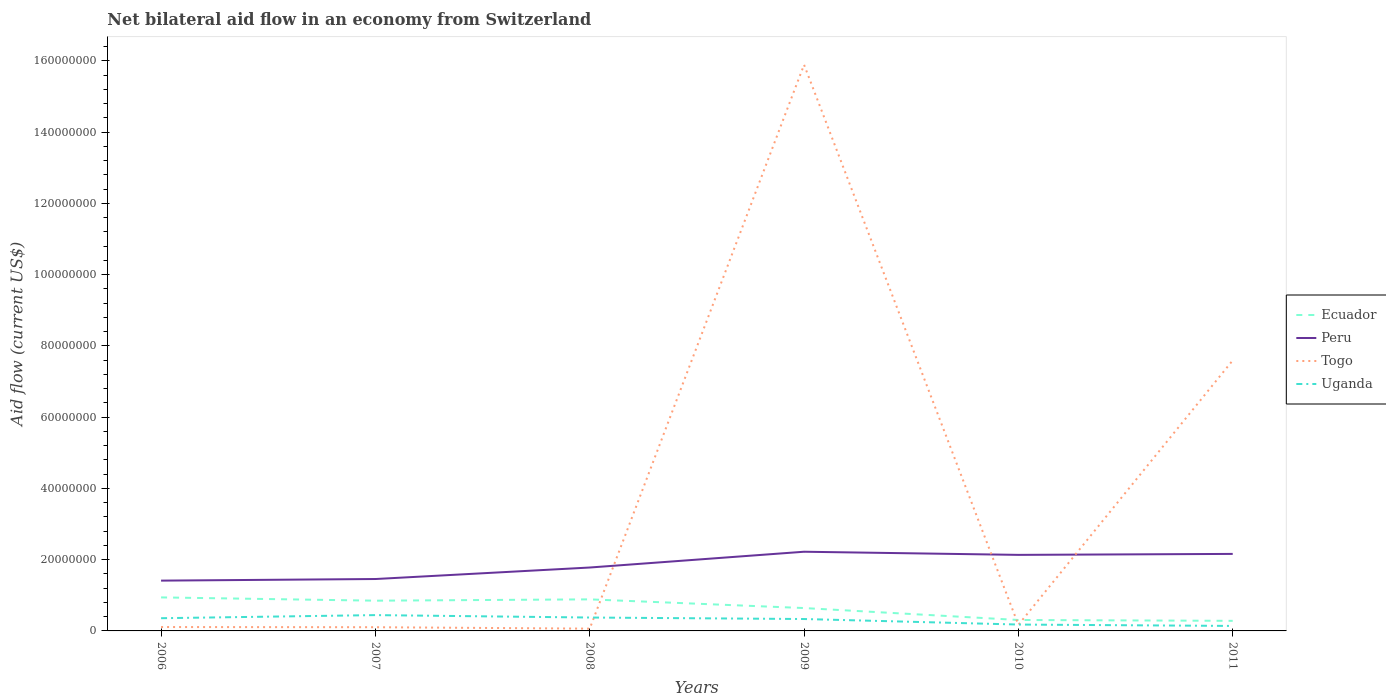How many different coloured lines are there?
Give a very brief answer. 4. Does the line corresponding to Ecuador intersect with the line corresponding to Uganda?
Your answer should be very brief. No. Across all years, what is the maximum net bilateral aid flow in Ecuador?
Your response must be concise. 2.83e+06. In which year was the net bilateral aid flow in Ecuador maximum?
Make the answer very short. 2011. What is the total net bilateral aid flow in Togo in the graph?
Your answer should be very brief. -1.58e+08. What is the difference between the highest and the second highest net bilateral aid flow in Uganda?
Give a very brief answer. 3.04e+06. What is the difference between the highest and the lowest net bilateral aid flow in Togo?
Offer a terse response. 2. How many years are there in the graph?
Ensure brevity in your answer.  6. Does the graph contain grids?
Offer a very short reply. No. How many legend labels are there?
Ensure brevity in your answer.  4. What is the title of the graph?
Your answer should be compact. Net bilateral aid flow in an economy from Switzerland. What is the label or title of the Y-axis?
Offer a terse response. Aid flow (current US$). What is the Aid flow (current US$) in Ecuador in 2006?
Keep it short and to the point. 9.41e+06. What is the Aid flow (current US$) of Peru in 2006?
Ensure brevity in your answer.  1.41e+07. What is the Aid flow (current US$) in Togo in 2006?
Provide a short and direct response. 1.09e+06. What is the Aid flow (current US$) of Uganda in 2006?
Your answer should be compact. 3.57e+06. What is the Aid flow (current US$) in Ecuador in 2007?
Ensure brevity in your answer.  8.49e+06. What is the Aid flow (current US$) of Peru in 2007?
Offer a terse response. 1.46e+07. What is the Aid flow (current US$) in Togo in 2007?
Keep it short and to the point. 1.04e+06. What is the Aid flow (current US$) of Uganda in 2007?
Make the answer very short. 4.44e+06. What is the Aid flow (current US$) in Ecuador in 2008?
Give a very brief answer. 8.86e+06. What is the Aid flow (current US$) of Peru in 2008?
Provide a short and direct response. 1.78e+07. What is the Aid flow (current US$) in Togo in 2008?
Provide a short and direct response. 6.40e+05. What is the Aid flow (current US$) of Uganda in 2008?
Provide a short and direct response. 3.76e+06. What is the Aid flow (current US$) in Ecuador in 2009?
Offer a very short reply. 6.42e+06. What is the Aid flow (current US$) of Peru in 2009?
Your response must be concise. 2.22e+07. What is the Aid flow (current US$) of Togo in 2009?
Ensure brevity in your answer.  1.59e+08. What is the Aid flow (current US$) of Uganda in 2009?
Your answer should be very brief. 3.34e+06. What is the Aid flow (current US$) of Ecuador in 2010?
Ensure brevity in your answer.  3.07e+06. What is the Aid flow (current US$) in Peru in 2010?
Your answer should be very brief. 2.14e+07. What is the Aid flow (current US$) in Togo in 2010?
Provide a short and direct response. 1.71e+06. What is the Aid flow (current US$) of Uganda in 2010?
Your answer should be compact. 1.79e+06. What is the Aid flow (current US$) in Ecuador in 2011?
Offer a very short reply. 2.83e+06. What is the Aid flow (current US$) of Peru in 2011?
Make the answer very short. 2.16e+07. What is the Aid flow (current US$) in Togo in 2011?
Provide a short and direct response. 7.60e+07. What is the Aid flow (current US$) of Uganda in 2011?
Provide a short and direct response. 1.40e+06. Across all years, what is the maximum Aid flow (current US$) of Ecuador?
Your answer should be very brief. 9.41e+06. Across all years, what is the maximum Aid flow (current US$) in Peru?
Provide a succinct answer. 2.22e+07. Across all years, what is the maximum Aid flow (current US$) in Togo?
Your response must be concise. 1.59e+08. Across all years, what is the maximum Aid flow (current US$) in Uganda?
Offer a terse response. 4.44e+06. Across all years, what is the minimum Aid flow (current US$) in Ecuador?
Give a very brief answer. 2.83e+06. Across all years, what is the minimum Aid flow (current US$) of Peru?
Keep it short and to the point. 1.41e+07. Across all years, what is the minimum Aid flow (current US$) of Togo?
Keep it short and to the point. 6.40e+05. Across all years, what is the minimum Aid flow (current US$) in Uganda?
Give a very brief answer. 1.40e+06. What is the total Aid flow (current US$) in Ecuador in the graph?
Ensure brevity in your answer.  3.91e+07. What is the total Aid flow (current US$) of Peru in the graph?
Offer a very short reply. 1.12e+08. What is the total Aid flow (current US$) in Togo in the graph?
Ensure brevity in your answer.  2.39e+08. What is the total Aid flow (current US$) of Uganda in the graph?
Offer a terse response. 1.83e+07. What is the difference between the Aid flow (current US$) in Ecuador in 2006 and that in 2007?
Offer a terse response. 9.20e+05. What is the difference between the Aid flow (current US$) of Peru in 2006 and that in 2007?
Your response must be concise. -4.50e+05. What is the difference between the Aid flow (current US$) in Togo in 2006 and that in 2007?
Give a very brief answer. 5.00e+04. What is the difference between the Aid flow (current US$) in Uganda in 2006 and that in 2007?
Give a very brief answer. -8.70e+05. What is the difference between the Aid flow (current US$) in Ecuador in 2006 and that in 2008?
Make the answer very short. 5.50e+05. What is the difference between the Aid flow (current US$) in Peru in 2006 and that in 2008?
Your response must be concise. -3.68e+06. What is the difference between the Aid flow (current US$) in Ecuador in 2006 and that in 2009?
Your answer should be very brief. 2.99e+06. What is the difference between the Aid flow (current US$) of Peru in 2006 and that in 2009?
Give a very brief answer. -8.11e+06. What is the difference between the Aid flow (current US$) of Togo in 2006 and that in 2009?
Make the answer very short. -1.58e+08. What is the difference between the Aid flow (current US$) in Uganda in 2006 and that in 2009?
Provide a short and direct response. 2.30e+05. What is the difference between the Aid flow (current US$) in Ecuador in 2006 and that in 2010?
Give a very brief answer. 6.34e+06. What is the difference between the Aid flow (current US$) of Peru in 2006 and that in 2010?
Make the answer very short. -7.23e+06. What is the difference between the Aid flow (current US$) in Togo in 2006 and that in 2010?
Keep it short and to the point. -6.20e+05. What is the difference between the Aid flow (current US$) of Uganda in 2006 and that in 2010?
Provide a short and direct response. 1.78e+06. What is the difference between the Aid flow (current US$) in Ecuador in 2006 and that in 2011?
Give a very brief answer. 6.58e+06. What is the difference between the Aid flow (current US$) of Peru in 2006 and that in 2011?
Offer a terse response. -7.50e+06. What is the difference between the Aid flow (current US$) in Togo in 2006 and that in 2011?
Ensure brevity in your answer.  -7.49e+07. What is the difference between the Aid flow (current US$) of Uganda in 2006 and that in 2011?
Make the answer very short. 2.17e+06. What is the difference between the Aid flow (current US$) of Ecuador in 2007 and that in 2008?
Offer a terse response. -3.70e+05. What is the difference between the Aid flow (current US$) in Peru in 2007 and that in 2008?
Provide a succinct answer. -3.23e+06. What is the difference between the Aid flow (current US$) of Uganda in 2007 and that in 2008?
Make the answer very short. 6.80e+05. What is the difference between the Aid flow (current US$) in Ecuador in 2007 and that in 2009?
Provide a succinct answer. 2.07e+06. What is the difference between the Aid flow (current US$) of Peru in 2007 and that in 2009?
Provide a short and direct response. -7.66e+06. What is the difference between the Aid flow (current US$) in Togo in 2007 and that in 2009?
Keep it short and to the point. -1.58e+08. What is the difference between the Aid flow (current US$) in Uganda in 2007 and that in 2009?
Offer a terse response. 1.10e+06. What is the difference between the Aid flow (current US$) in Ecuador in 2007 and that in 2010?
Provide a short and direct response. 5.42e+06. What is the difference between the Aid flow (current US$) of Peru in 2007 and that in 2010?
Your answer should be very brief. -6.78e+06. What is the difference between the Aid flow (current US$) in Togo in 2007 and that in 2010?
Offer a terse response. -6.70e+05. What is the difference between the Aid flow (current US$) in Uganda in 2007 and that in 2010?
Your answer should be very brief. 2.65e+06. What is the difference between the Aid flow (current US$) of Ecuador in 2007 and that in 2011?
Your response must be concise. 5.66e+06. What is the difference between the Aid flow (current US$) of Peru in 2007 and that in 2011?
Your answer should be compact. -7.05e+06. What is the difference between the Aid flow (current US$) in Togo in 2007 and that in 2011?
Make the answer very short. -7.49e+07. What is the difference between the Aid flow (current US$) in Uganda in 2007 and that in 2011?
Keep it short and to the point. 3.04e+06. What is the difference between the Aid flow (current US$) of Ecuador in 2008 and that in 2009?
Offer a very short reply. 2.44e+06. What is the difference between the Aid flow (current US$) of Peru in 2008 and that in 2009?
Make the answer very short. -4.43e+06. What is the difference between the Aid flow (current US$) of Togo in 2008 and that in 2009?
Give a very brief answer. -1.58e+08. What is the difference between the Aid flow (current US$) of Ecuador in 2008 and that in 2010?
Ensure brevity in your answer.  5.79e+06. What is the difference between the Aid flow (current US$) of Peru in 2008 and that in 2010?
Give a very brief answer. -3.55e+06. What is the difference between the Aid flow (current US$) of Togo in 2008 and that in 2010?
Provide a short and direct response. -1.07e+06. What is the difference between the Aid flow (current US$) in Uganda in 2008 and that in 2010?
Offer a very short reply. 1.97e+06. What is the difference between the Aid flow (current US$) of Ecuador in 2008 and that in 2011?
Your answer should be compact. 6.03e+06. What is the difference between the Aid flow (current US$) in Peru in 2008 and that in 2011?
Your answer should be compact. -3.82e+06. What is the difference between the Aid flow (current US$) in Togo in 2008 and that in 2011?
Offer a terse response. -7.53e+07. What is the difference between the Aid flow (current US$) of Uganda in 2008 and that in 2011?
Provide a succinct answer. 2.36e+06. What is the difference between the Aid flow (current US$) in Ecuador in 2009 and that in 2010?
Your answer should be compact. 3.35e+06. What is the difference between the Aid flow (current US$) in Peru in 2009 and that in 2010?
Ensure brevity in your answer.  8.80e+05. What is the difference between the Aid flow (current US$) of Togo in 2009 and that in 2010?
Offer a very short reply. 1.57e+08. What is the difference between the Aid flow (current US$) of Uganda in 2009 and that in 2010?
Provide a short and direct response. 1.55e+06. What is the difference between the Aid flow (current US$) in Ecuador in 2009 and that in 2011?
Ensure brevity in your answer.  3.59e+06. What is the difference between the Aid flow (current US$) in Peru in 2009 and that in 2011?
Keep it short and to the point. 6.10e+05. What is the difference between the Aid flow (current US$) of Togo in 2009 and that in 2011?
Make the answer very short. 8.30e+07. What is the difference between the Aid flow (current US$) of Uganda in 2009 and that in 2011?
Provide a short and direct response. 1.94e+06. What is the difference between the Aid flow (current US$) in Peru in 2010 and that in 2011?
Your response must be concise. -2.70e+05. What is the difference between the Aid flow (current US$) in Togo in 2010 and that in 2011?
Keep it short and to the point. -7.42e+07. What is the difference between the Aid flow (current US$) in Ecuador in 2006 and the Aid flow (current US$) in Peru in 2007?
Keep it short and to the point. -5.16e+06. What is the difference between the Aid flow (current US$) of Ecuador in 2006 and the Aid flow (current US$) of Togo in 2007?
Keep it short and to the point. 8.37e+06. What is the difference between the Aid flow (current US$) in Ecuador in 2006 and the Aid flow (current US$) in Uganda in 2007?
Keep it short and to the point. 4.97e+06. What is the difference between the Aid flow (current US$) of Peru in 2006 and the Aid flow (current US$) of Togo in 2007?
Keep it short and to the point. 1.31e+07. What is the difference between the Aid flow (current US$) of Peru in 2006 and the Aid flow (current US$) of Uganda in 2007?
Keep it short and to the point. 9.68e+06. What is the difference between the Aid flow (current US$) in Togo in 2006 and the Aid flow (current US$) in Uganda in 2007?
Your answer should be compact. -3.35e+06. What is the difference between the Aid flow (current US$) of Ecuador in 2006 and the Aid flow (current US$) of Peru in 2008?
Offer a terse response. -8.39e+06. What is the difference between the Aid flow (current US$) of Ecuador in 2006 and the Aid flow (current US$) of Togo in 2008?
Your answer should be compact. 8.77e+06. What is the difference between the Aid flow (current US$) in Ecuador in 2006 and the Aid flow (current US$) in Uganda in 2008?
Provide a succinct answer. 5.65e+06. What is the difference between the Aid flow (current US$) of Peru in 2006 and the Aid flow (current US$) of Togo in 2008?
Your answer should be very brief. 1.35e+07. What is the difference between the Aid flow (current US$) in Peru in 2006 and the Aid flow (current US$) in Uganda in 2008?
Provide a short and direct response. 1.04e+07. What is the difference between the Aid flow (current US$) of Togo in 2006 and the Aid flow (current US$) of Uganda in 2008?
Your response must be concise. -2.67e+06. What is the difference between the Aid flow (current US$) of Ecuador in 2006 and the Aid flow (current US$) of Peru in 2009?
Give a very brief answer. -1.28e+07. What is the difference between the Aid flow (current US$) in Ecuador in 2006 and the Aid flow (current US$) in Togo in 2009?
Offer a terse response. -1.50e+08. What is the difference between the Aid flow (current US$) in Ecuador in 2006 and the Aid flow (current US$) in Uganda in 2009?
Provide a short and direct response. 6.07e+06. What is the difference between the Aid flow (current US$) of Peru in 2006 and the Aid flow (current US$) of Togo in 2009?
Ensure brevity in your answer.  -1.45e+08. What is the difference between the Aid flow (current US$) in Peru in 2006 and the Aid flow (current US$) in Uganda in 2009?
Give a very brief answer. 1.08e+07. What is the difference between the Aid flow (current US$) in Togo in 2006 and the Aid flow (current US$) in Uganda in 2009?
Ensure brevity in your answer.  -2.25e+06. What is the difference between the Aid flow (current US$) in Ecuador in 2006 and the Aid flow (current US$) in Peru in 2010?
Make the answer very short. -1.19e+07. What is the difference between the Aid flow (current US$) of Ecuador in 2006 and the Aid flow (current US$) of Togo in 2010?
Provide a succinct answer. 7.70e+06. What is the difference between the Aid flow (current US$) in Ecuador in 2006 and the Aid flow (current US$) in Uganda in 2010?
Your answer should be compact. 7.62e+06. What is the difference between the Aid flow (current US$) in Peru in 2006 and the Aid flow (current US$) in Togo in 2010?
Make the answer very short. 1.24e+07. What is the difference between the Aid flow (current US$) of Peru in 2006 and the Aid flow (current US$) of Uganda in 2010?
Your response must be concise. 1.23e+07. What is the difference between the Aid flow (current US$) in Togo in 2006 and the Aid flow (current US$) in Uganda in 2010?
Ensure brevity in your answer.  -7.00e+05. What is the difference between the Aid flow (current US$) in Ecuador in 2006 and the Aid flow (current US$) in Peru in 2011?
Your response must be concise. -1.22e+07. What is the difference between the Aid flow (current US$) in Ecuador in 2006 and the Aid flow (current US$) in Togo in 2011?
Ensure brevity in your answer.  -6.65e+07. What is the difference between the Aid flow (current US$) in Ecuador in 2006 and the Aid flow (current US$) in Uganda in 2011?
Your answer should be compact. 8.01e+06. What is the difference between the Aid flow (current US$) in Peru in 2006 and the Aid flow (current US$) in Togo in 2011?
Provide a succinct answer. -6.18e+07. What is the difference between the Aid flow (current US$) in Peru in 2006 and the Aid flow (current US$) in Uganda in 2011?
Your response must be concise. 1.27e+07. What is the difference between the Aid flow (current US$) in Togo in 2006 and the Aid flow (current US$) in Uganda in 2011?
Ensure brevity in your answer.  -3.10e+05. What is the difference between the Aid flow (current US$) in Ecuador in 2007 and the Aid flow (current US$) in Peru in 2008?
Provide a succinct answer. -9.31e+06. What is the difference between the Aid flow (current US$) in Ecuador in 2007 and the Aid flow (current US$) in Togo in 2008?
Keep it short and to the point. 7.85e+06. What is the difference between the Aid flow (current US$) in Ecuador in 2007 and the Aid flow (current US$) in Uganda in 2008?
Your answer should be very brief. 4.73e+06. What is the difference between the Aid flow (current US$) of Peru in 2007 and the Aid flow (current US$) of Togo in 2008?
Provide a succinct answer. 1.39e+07. What is the difference between the Aid flow (current US$) in Peru in 2007 and the Aid flow (current US$) in Uganda in 2008?
Your response must be concise. 1.08e+07. What is the difference between the Aid flow (current US$) in Togo in 2007 and the Aid flow (current US$) in Uganda in 2008?
Your response must be concise. -2.72e+06. What is the difference between the Aid flow (current US$) in Ecuador in 2007 and the Aid flow (current US$) in Peru in 2009?
Keep it short and to the point. -1.37e+07. What is the difference between the Aid flow (current US$) of Ecuador in 2007 and the Aid flow (current US$) of Togo in 2009?
Offer a very short reply. -1.50e+08. What is the difference between the Aid flow (current US$) of Ecuador in 2007 and the Aid flow (current US$) of Uganda in 2009?
Provide a short and direct response. 5.15e+06. What is the difference between the Aid flow (current US$) in Peru in 2007 and the Aid flow (current US$) in Togo in 2009?
Offer a terse response. -1.44e+08. What is the difference between the Aid flow (current US$) of Peru in 2007 and the Aid flow (current US$) of Uganda in 2009?
Your answer should be very brief. 1.12e+07. What is the difference between the Aid flow (current US$) of Togo in 2007 and the Aid flow (current US$) of Uganda in 2009?
Offer a terse response. -2.30e+06. What is the difference between the Aid flow (current US$) in Ecuador in 2007 and the Aid flow (current US$) in Peru in 2010?
Offer a terse response. -1.29e+07. What is the difference between the Aid flow (current US$) of Ecuador in 2007 and the Aid flow (current US$) of Togo in 2010?
Your answer should be compact. 6.78e+06. What is the difference between the Aid flow (current US$) of Ecuador in 2007 and the Aid flow (current US$) of Uganda in 2010?
Make the answer very short. 6.70e+06. What is the difference between the Aid flow (current US$) in Peru in 2007 and the Aid flow (current US$) in Togo in 2010?
Your answer should be compact. 1.29e+07. What is the difference between the Aid flow (current US$) in Peru in 2007 and the Aid flow (current US$) in Uganda in 2010?
Keep it short and to the point. 1.28e+07. What is the difference between the Aid flow (current US$) in Togo in 2007 and the Aid flow (current US$) in Uganda in 2010?
Your answer should be very brief. -7.50e+05. What is the difference between the Aid flow (current US$) in Ecuador in 2007 and the Aid flow (current US$) in Peru in 2011?
Make the answer very short. -1.31e+07. What is the difference between the Aid flow (current US$) in Ecuador in 2007 and the Aid flow (current US$) in Togo in 2011?
Your answer should be compact. -6.75e+07. What is the difference between the Aid flow (current US$) of Ecuador in 2007 and the Aid flow (current US$) of Uganda in 2011?
Keep it short and to the point. 7.09e+06. What is the difference between the Aid flow (current US$) of Peru in 2007 and the Aid flow (current US$) of Togo in 2011?
Your answer should be very brief. -6.14e+07. What is the difference between the Aid flow (current US$) of Peru in 2007 and the Aid flow (current US$) of Uganda in 2011?
Provide a short and direct response. 1.32e+07. What is the difference between the Aid flow (current US$) in Togo in 2007 and the Aid flow (current US$) in Uganda in 2011?
Give a very brief answer. -3.60e+05. What is the difference between the Aid flow (current US$) in Ecuador in 2008 and the Aid flow (current US$) in Peru in 2009?
Ensure brevity in your answer.  -1.34e+07. What is the difference between the Aid flow (current US$) of Ecuador in 2008 and the Aid flow (current US$) of Togo in 2009?
Keep it short and to the point. -1.50e+08. What is the difference between the Aid flow (current US$) in Ecuador in 2008 and the Aid flow (current US$) in Uganda in 2009?
Your answer should be very brief. 5.52e+06. What is the difference between the Aid flow (current US$) in Peru in 2008 and the Aid flow (current US$) in Togo in 2009?
Your answer should be very brief. -1.41e+08. What is the difference between the Aid flow (current US$) of Peru in 2008 and the Aid flow (current US$) of Uganda in 2009?
Your answer should be compact. 1.45e+07. What is the difference between the Aid flow (current US$) of Togo in 2008 and the Aid flow (current US$) of Uganda in 2009?
Keep it short and to the point. -2.70e+06. What is the difference between the Aid flow (current US$) in Ecuador in 2008 and the Aid flow (current US$) in Peru in 2010?
Your answer should be compact. -1.25e+07. What is the difference between the Aid flow (current US$) of Ecuador in 2008 and the Aid flow (current US$) of Togo in 2010?
Give a very brief answer. 7.15e+06. What is the difference between the Aid flow (current US$) of Ecuador in 2008 and the Aid flow (current US$) of Uganda in 2010?
Your response must be concise. 7.07e+06. What is the difference between the Aid flow (current US$) in Peru in 2008 and the Aid flow (current US$) in Togo in 2010?
Give a very brief answer. 1.61e+07. What is the difference between the Aid flow (current US$) of Peru in 2008 and the Aid flow (current US$) of Uganda in 2010?
Give a very brief answer. 1.60e+07. What is the difference between the Aid flow (current US$) in Togo in 2008 and the Aid flow (current US$) in Uganda in 2010?
Provide a short and direct response. -1.15e+06. What is the difference between the Aid flow (current US$) of Ecuador in 2008 and the Aid flow (current US$) of Peru in 2011?
Provide a succinct answer. -1.28e+07. What is the difference between the Aid flow (current US$) of Ecuador in 2008 and the Aid flow (current US$) of Togo in 2011?
Provide a succinct answer. -6.71e+07. What is the difference between the Aid flow (current US$) in Ecuador in 2008 and the Aid flow (current US$) in Uganda in 2011?
Your answer should be very brief. 7.46e+06. What is the difference between the Aid flow (current US$) of Peru in 2008 and the Aid flow (current US$) of Togo in 2011?
Provide a short and direct response. -5.82e+07. What is the difference between the Aid flow (current US$) of Peru in 2008 and the Aid flow (current US$) of Uganda in 2011?
Keep it short and to the point. 1.64e+07. What is the difference between the Aid flow (current US$) in Togo in 2008 and the Aid flow (current US$) in Uganda in 2011?
Offer a very short reply. -7.60e+05. What is the difference between the Aid flow (current US$) of Ecuador in 2009 and the Aid flow (current US$) of Peru in 2010?
Keep it short and to the point. -1.49e+07. What is the difference between the Aid flow (current US$) in Ecuador in 2009 and the Aid flow (current US$) in Togo in 2010?
Give a very brief answer. 4.71e+06. What is the difference between the Aid flow (current US$) in Ecuador in 2009 and the Aid flow (current US$) in Uganda in 2010?
Provide a short and direct response. 4.63e+06. What is the difference between the Aid flow (current US$) of Peru in 2009 and the Aid flow (current US$) of Togo in 2010?
Give a very brief answer. 2.05e+07. What is the difference between the Aid flow (current US$) of Peru in 2009 and the Aid flow (current US$) of Uganda in 2010?
Your answer should be very brief. 2.04e+07. What is the difference between the Aid flow (current US$) in Togo in 2009 and the Aid flow (current US$) in Uganda in 2010?
Provide a short and direct response. 1.57e+08. What is the difference between the Aid flow (current US$) of Ecuador in 2009 and the Aid flow (current US$) of Peru in 2011?
Provide a succinct answer. -1.52e+07. What is the difference between the Aid flow (current US$) of Ecuador in 2009 and the Aid flow (current US$) of Togo in 2011?
Offer a terse response. -6.95e+07. What is the difference between the Aid flow (current US$) of Ecuador in 2009 and the Aid flow (current US$) of Uganda in 2011?
Make the answer very short. 5.02e+06. What is the difference between the Aid flow (current US$) of Peru in 2009 and the Aid flow (current US$) of Togo in 2011?
Your answer should be very brief. -5.37e+07. What is the difference between the Aid flow (current US$) in Peru in 2009 and the Aid flow (current US$) in Uganda in 2011?
Offer a terse response. 2.08e+07. What is the difference between the Aid flow (current US$) of Togo in 2009 and the Aid flow (current US$) of Uganda in 2011?
Keep it short and to the point. 1.58e+08. What is the difference between the Aid flow (current US$) in Ecuador in 2010 and the Aid flow (current US$) in Peru in 2011?
Your response must be concise. -1.86e+07. What is the difference between the Aid flow (current US$) of Ecuador in 2010 and the Aid flow (current US$) of Togo in 2011?
Your answer should be compact. -7.29e+07. What is the difference between the Aid flow (current US$) in Ecuador in 2010 and the Aid flow (current US$) in Uganda in 2011?
Keep it short and to the point. 1.67e+06. What is the difference between the Aid flow (current US$) of Peru in 2010 and the Aid flow (current US$) of Togo in 2011?
Provide a short and direct response. -5.46e+07. What is the difference between the Aid flow (current US$) in Peru in 2010 and the Aid flow (current US$) in Uganda in 2011?
Offer a terse response. 2.00e+07. What is the difference between the Aid flow (current US$) of Togo in 2010 and the Aid flow (current US$) of Uganda in 2011?
Make the answer very short. 3.10e+05. What is the average Aid flow (current US$) of Ecuador per year?
Offer a terse response. 6.51e+06. What is the average Aid flow (current US$) in Peru per year?
Your answer should be very brief. 1.86e+07. What is the average Aid flow (current US$) in Togo per year?
Provide a short and direct response. 3.99e+07. What is the average Aid flow (current US$) in Uganda per year?
Offer a terse response. 3.05e+06. In the year 2006, what is the difference between the Aid flow (current US$) of Ecuador and Aid flow (current US$) of Peru?
Give a very brief answer. -4.71e+06. In the year 2006, what is the difference between the Aid flow (current US$) of Ecuador and Aid flow (current US$) of Togo?
Provide a short and direct response. 8.32e+06. In the year 2006, what is the difference between the Aid flow (current US$) of Ecuador and Aid flow (current US$) of Uganda?
Keep it short and to the point. 5.84e+06. In the year 2006, what is the difference between the Aid flow (current US$) in Peru and Aid flow (current US$) in Togo?
Offer a terse response. 1.30e+07. In the year 2006, what is the difference between the Aid flow (current US$) of Peru and Aid flow (current US$) of Uganda?
Offer a very short reply. 1.06e+07. In the year 2006, what is the difference between the Aid flow (current US$) of Togo and Aid flow (current US$) of Uganda?
Your answer should be compact. -2.48e+06. In the year 2007, what is the difference between the Aid flow (current US$) of Ecuador and Aid flow (current US$) of Peru?
Your answer should be very brief. -6.08e+06. In the year 2007, what is the difference between the Aid flow (current US$) of Ecuador and Aid flow (current US$) of Togo?
Provide a short and direct response. 7.45e+06. In the year 2007, what is the difference between the Aid flow (current US$) of Ecuador and Aid flow (current US$) of Uganda?
Provide a succinct answer. 4.05e+06. In the year 2007, what is the difference between the Aid flow (current US$) of Peru and Aid flow (current US$) of Togo?
Keep it short and to the point. 1.35e+07. In the year 2007, what is the difference between the Aid flow (current US$) in Peru and Aid flow (current US$) in Uganda?
Your response must be concise. 1.01e+07. In the year 2007, what is the difference between the Aid flow (current US$) in Togo and Aid flow (current US$) in Uganda?
Offer a very short reply. -3.40e+06. In the year 2008, what is the difference between the Aid flow (current US$) in Ecuador and Aid flow (current US$) in Peru?
Your answer should be very brief. -8.94e+06. In the year 2008, what is the difference between the Aid flow (current US$) of Ecuador and Aid flow (current US$) of Togo?
Make the answer very short. 8.22e+06. In the year 2008, what is the difference between the Aid flow (current US$) of Ecuador and Aid flow (current US$) of Uganda?
Give a very brief answer. 5.10e+06. In the year 2008, what is the difference between the Aid flow (current US$) of Peru and Aid flow (current US$) of Togo?
Give a very brief answer. 1.72e+07. In the year 2008, what is the difference between the Aid flow (current US$) of Peru and Aid flow (current US$) of Uganda?
Your response must be concise. 1.40e+07. In the year 2008, what is the difference between the Aid flow (current US$) in Togo and Aid flow (current US$) in Uganda?
Your answer should be compact. -3.12e+06. In the year 2009, what is the difference between the Aid flow (current US$) in Ecuador and Aid flow (current US$) in Peru?
Provide a succinct answer. -1.58e+07. In the year 2009, what is the difference between the Aid flow (current US$) of Ecuador and Aid flow (current US$) of Togo?
Your answer should be compact. -1.53e+08. In the year 2009, what is the difference between the Aid flow (current US$) of Ecuador and Aid flow (current US$) of Uganda?
Your answer should be compact. 3.08e+06. In the year 2009, what is the difference between the Aid flow (current US$) in Peru and Aid flow (current US$) in Togo?
Ensure brevity in your answer.  -1.37e+08. In the year 2009, what is the difference between the Aid flow (current US$) of Peru and Aid flow (current US$) of Uganda?
Give a very brief answer. 1.89e+07. In the year 2009, what is the difference between the Aid flow (current US$) in Togo and Aid flow (current US$) in Uganda?
Give a very brief answer. 1.56e+08. In the year 2010, what is the difference between the Aid flow (current US$) in Ecuador and Aid flow (current US$) in Peru?
Make the answer very short. -1.83e+07. In the year 2010, what is the difference between the Aid flow (current US$) of Ecuador and Aid flow (current US$) of Togo?
Your answer should be very brief. 1.36e+06. In the year 2010, what is the difference between the Aid flow (current US$) in Ecuador and Aid flow (current US$) in Uganda?
Your answer should be very brief. 1.28e+06. In the year 2010, what is the difference between the Aid flow (current US$) of Peru and Aid flow (current US$) of Togo?
Offer a terse response. 1.96e+07. In the year 2010, what is the difference between the Aid flow (current US$) in Peru and Aid flow (current US$) in Uganda?
Your response must be concise. 1.96e+07. In the year 2011, what is the difference between the Aid flow (current US$) in Ecuador and Aid flow (current US$) in Peru?
Provide a short and direct response. -1.88e+07. In the year 2011, what is the difference between the Aid flow (current US$) of Ecuador and Aid flow (current US$) of Togo?
Offer a very short reply. -7.31e+07. In the year 2011, what is the difference between the Aid flow (current US$) of Ecuador and Aid flow (current US$) of Uganda?
Ensure brevity in your answer.  1.43e+06. In the year 2011, what is the difference between the Aid flow (current US$) in Peru and Aid flow (current US$) in Togo?
Give a very brief answer. -5.43e+07. In the year 2011, what is the difference between the Aid flow (current US$) of Peru and Aid flow (current US$) of Uganda?
Provide a short and direct response. 2.02e+07. In the year 2011, what is the difference between the Aid flow (current US$) of Togo and Aid flow (current US$) of Uganda?
Your answer should be very brief. 7.46e+07. What is the ratio of the Aid flow (current US$) in Ecuador in 2006 to that in 2007?
Your answer should be very brief. 1.11. What is the ratio of the Aid flow (current US$) of Peru in 2006 to that in 2007?
Provide a succinct answer. 0.97. What is the ratio of the Aid flow (current US$) in Togo in 2006 to that in 2007?
Your answer should be compact. 1.05. What is the ratio of the Aid flow (current US$) of Uganda in 2006 to that in 2007?
Make the answer very short. 0.8. What is the ratio of the Aid flow (current US$) in Ecuador in 2006 to that in 2008?
Keep it short and to the point. 1.06. What is the ratio of the Aid flow (current US$) of Peru in 2006 to that in 2008?
Your response must be concise. 0.79. What is the ratio of the Aid flow (current US$) of Togo in 2006 to that in 2008?
Give a very brief answer. 1.7. What is the ratio of the Aid flow (current US$) in Uganda in 2006 to that in 2008?
Your answer should be compact. 0.95. What is the ratio of the Aid flow (current US$) of Ecuador in 2006 to that in 2009?
Ensure brevity in your answer.  1.47. What is the ratio of the Aid flow (current US$) in Peru in 2006 to that in 2009?
Your answer should be very brief. 0.64. What is the ratio of the Aid flow (current US$) in Togo in 2006 to that in 2009?
Give a very brief answer. 0.01. What is the ratio of the Aid flow (current US$) of Uganda in 2006 to that in 2009?
Provide a succinct answer. 1.07. What is the ratio of the Aid flow (current US$) of Ecuador in 2006 to that in 2010?
Provide a succinct answer. 3.07. What is the ratio of the Aid flow (current US$) of Peru in 2006 to that in 2010?
Make the answer very short. 0.66. What is the ratio of the Aid flow (current US$) of Togo in 2006 to that in 2010?
Ensure brevity in your answer.  0.64. What is the ratio of the Aid flow (current US$) of Uganda in 2006 to that in 2010?
Offer a terse response. 1.99. What is the ratio of the Aid flow (current US$) in Ecuador in 2006 to that in 2011?
Give a very brief answer. 3.33. What is the ratio of the Aid flow (current US$) of Peru in 2006 to that in 2011?
Your answer should be compact. 0.65. What is the ratio of the Aid flow (current US$) of Togo in 2006 to that in 2011?
Your answer should be very brief. 0.01. What is the ratio of the Aid flow (current US$) in Uganda in 2006 to that in 2011?
Provide a short and direct response. 2.55. What is the ratio of the Aid flow (current US$) of Ecuador in 2007 to that in 2008?
Make the answer very short. 0.96. What is the ratio of the Aid flow (current US$) of Peru in 2007 to that in 2008?
Your answer should be compact. 0.82. What is the ratio of the Aid flow (current US$) in Togo in 2007 to that in 2008?
Your response must be concise. 1.62. What is the ratio of the Aid flow (current US$) in Uganda in 2007 to that in 2008?
Offer a very short reply. 1.18. What is the ratio of the Aid flow (current US$) in Ecuador in 2007 to that in 2009?
Make the answer very short. 1.32. What is the ratio of the Aid flow (current US$) in Peru in 2007 to that in 2009?
Provide a succinct answer. 0.66. What is the ratio of the Aid flow (current US$) of Togo in 2007 to that in 2009?
Keep it short and to the point. 0.01. What is the ratio of the Aid flow (current US$) in Uganda in 2007 to that in 2009?
Your answer should be very brief. 1.33. What is the ratio of the Aid flow (current US$) of Ecuador in 2007 to that in 2010?
Give a very brief answer. 2.77. What is the ratio of the Aid flow (current US$) in Peru in 2007 to that in 2010?
Provide a succinct answer. 0.68. What is the ratio of the Aid flow (current US$) in Togo in 2007 to that in 2010?
Your answer should be compact. 0.61. What is the ratio of the Aid flow (current US$) in Uganda in 2007 to that in 2010?
Ensure brevity in your answer.  2.48. What is the ratio of the Aid flow (current US$) of Ecuador in 2007 to that in 2011?
Your response must be concise. 3. What is the ratio of the Aid flow (current US$) in Peru in 2007 to that in 2011?
Provide a succinct answer. 0.67. What is the ratio of the Aid flow (current US$) in Togo in 2007 to that in 2011?
Your answer should be very brief. 0.01. What is the ratio of the Aid flow (current US$) of Uganda in 2007 to that in 2011?
Ensure brevity in your answer.  3.17. What is the ratio of the Aid flow (current US$) in Ecuador in 2008 to that in 2009?
Give a very brief answer. 1.38. What is the ratio of the Aid flow (current US$) in Peru in 2008 to that in 2009?
Give a very brief answer. 0.8. What is the ratio of the Aid flow (current US$) in Togo in 2008 to that in 2009?
Your answer should be very brief. 0. What is the ratio of the Aid flow (current US$) in Uganda in 2008 to that in 2009?
Ensure brevity in your answer.  1.13. What is the ratio of the Aid flow (current US$) in Ecuador in 2008 to that in 2010?
Make the answer very short. 2.89. What is the ratio of the Aid flow (current US$) in Peru in 2008 to that in 2010?
Make the answer very short. 0.83. What is the ratio of the Aid flow (current US$) of Togo in 2008 to that in 2010?
Offer a very short reply. 0.37. What is the ratio of the Aid flow (current US$) in Uganda in 2008 to that in 2010?
Ensure brevity in your answer.  2.1. What is the ratio of the Aid flow (current US$) of Ecuador in 2008 to that in 2011?
Keep it short and to the point. 3.13. What is the ratio of the Aid flow (current US$) in Peru in 2008 to that in 2011?
Keep it short and to the point. 0.82. What is the ratio of the Aid flow (current US$) of Togo in 2008 to that in 2011?
Provide a succinct answer. 0.01. What is the ratio of the Aid flow (current US$) in Uganda in 2008 to that in 2011?
Your response must be concise. 2.69. What is the ratio of the Aid flow (current US$) in Ecuador in 2009 to that in 2010?
Your answer should be very brief. 2.09. What is the ratio of the Aid flow (current US$) of Peru in 2009 to that in 2010?
Give a very brief answer. 1.04. What is the ratio of the Aid flow (current US$) of Togo in 2009 to that in 2010?
Keep it short and to the point. 92.95. What is the ratio of the Aid flow (current US$) of Uganda in 2009 to that in 2010?
Your response must be concise. 1.87. What is the ratio of the Aid flow (current US$) of Ecuador in 2009 to that in 2011?
Your response must be concise. 2.27. What is the ratio of the Aid flow (current US$) of Peru in 2009 to that in 2011?
Your answer should be compact. 1.03. What is the ratio of the Aid flow (current US$) of Togo in 2009 to that in 2011?
Offer a terse response. 2.09. What is the ratio of the Aid flow (current US$) of Uganda in 2009 to that in 2011?
Provide a succinct answer. 2.39. What is the ratio of the Aid flow (current US$) in Ecuador in 2010 to that in 2011?
Offer a very short reply. 1.08. What is the ratio of the Aid flow (current US$) in Peru in 2010 to that in 2011?
Offer a terse response. 0.99. What is the ratio of the Aid flow (current US$) in Togo in 2010 to that in 2011?
Provide a succinct answer. 0.02. What is the ratio of the Aid flow (current US$) of Uganda in 2010 to that in 2011?
Your answer should be very brief. 1.28. What is the difference between the highest and the second highest Aid flow (current US$) in Peru?
Your answer should be compact. 6.10e+05. What is the difference between the highest and the second highest Aid flow (current US$) of Togo?
Provide a short and direct response. 8.30e+07. What is the difference between the highest and the second highest Aid flow (current US$) in Uganda?
Your answer should be very brief. 6.80e+05. What is the difference between the highest and the lowest Aid flow (current US$) in Ecuador?
Your answer should be compact. 6.58e+06. What is the difference between the highest and the lowest Aid flow (current US$) of Peru?
Offer a terse response. 8.11e+06. What is the difference between the highest and the lowest Aid flow (current US$) of Togo?
Ensure brevity in your answer.  1.58e+08. What is the difference between the highest and the lowest Aid flow (current US$) of Uganda?
Offer a terse response. 3.04e+06. 